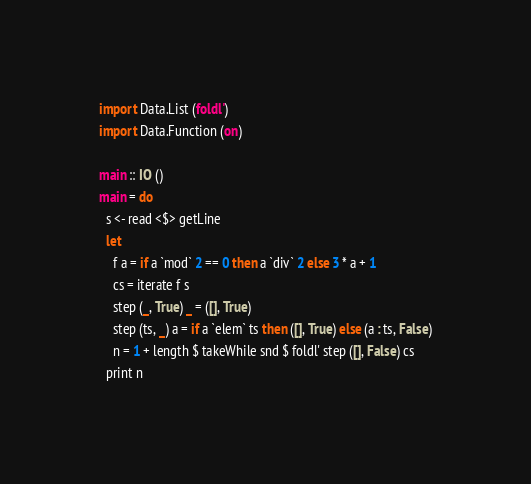<code> <loc_0><loc_0><loc_500><loc_500><_Haskell_>import Data.List (foldl')
import Data.Function (on)

main :: IO ()
main = do
  s <- read <$> getLine
  let
    f a = if a `mod` 2 == 0 then a `div` 2 else 3 * a + 1
    cs = iterate f s
    step (_, True) _ = ([], True)
    step (ts, _) a = if a `elem` ts then ([], True) else (a : ts, False)
    n = 1 + length $ takeWhile snd $ foldl' step ([], False) cs
  print n
</code> 